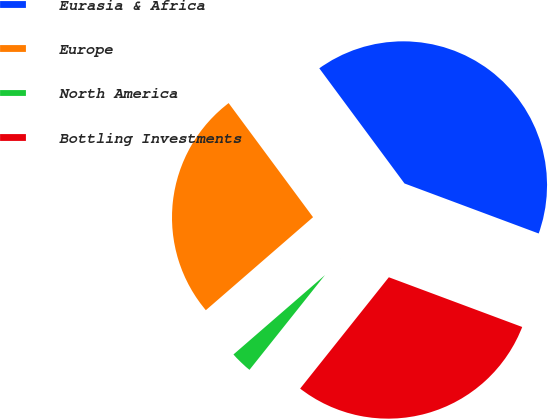Convert chart. <chart><loc_0><loc_0><loc_500><loc_500><pie_chart><fcel>Eurasia & Africa<fcel>Europe<fcel>North America<fcel>Bottling Investments<nl><fcel>40.82%<fcel>26.24%<fcel>2.92%<fcel>30.03%<nl></chart> 